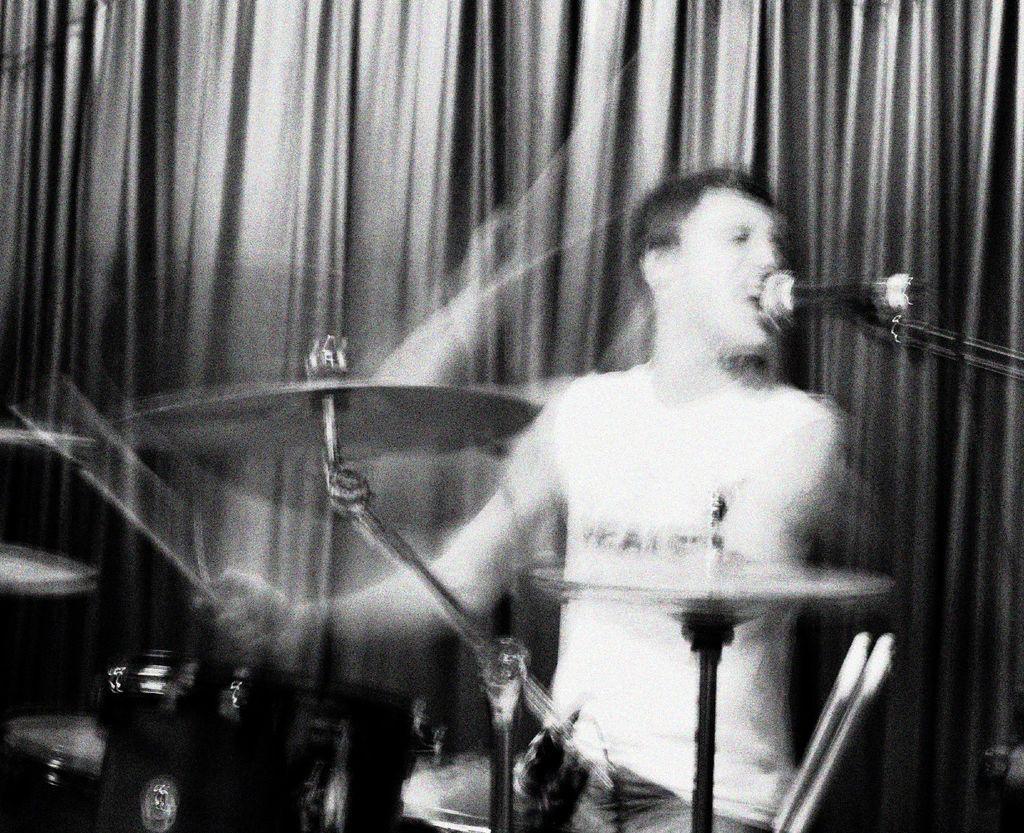Could you give a brief overview of what you see in this image? This is a black and white image. This picture might be taken inside the room. In this image, in the middle, we can see a man sitting and he is also playing musical instrument in front of a microphone. In the background, we can also see the curtains. 